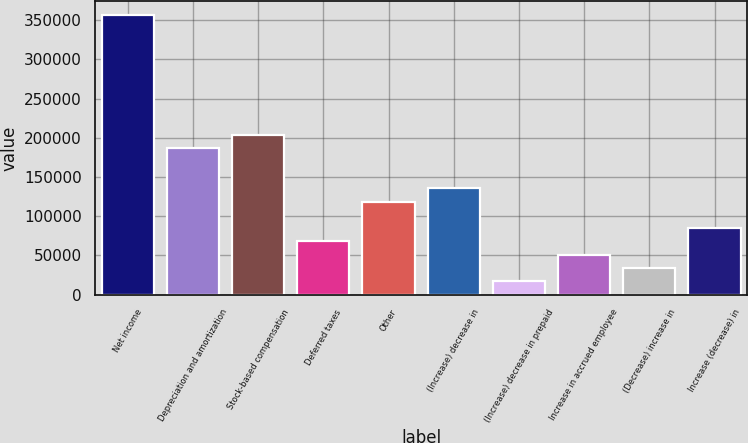Convert chart to OTSL. <chart><loc_0><loc_0><loc_500><loc_500><bar_chart><fcel>Net income<fcel>Depreciation and amortization<fcel>Stock-based compensation<fcel>Deferred taxes<fcel>Other<fcel>(Increase) decrease in<fcel>(Increase) decrease in prepaid<fcel>Increase in accrued employee<fcel>(Decrease) increase in<fcel>Increase (decrease) in<nl><fcel>356155<fcel>186578<fcel>203535<fcel>67873.8<fcel>118747<fcel>135705<fcel>17000.7<fcel>50916.1<fcel>33958.4<fcel>84831.5<nl></chart> 